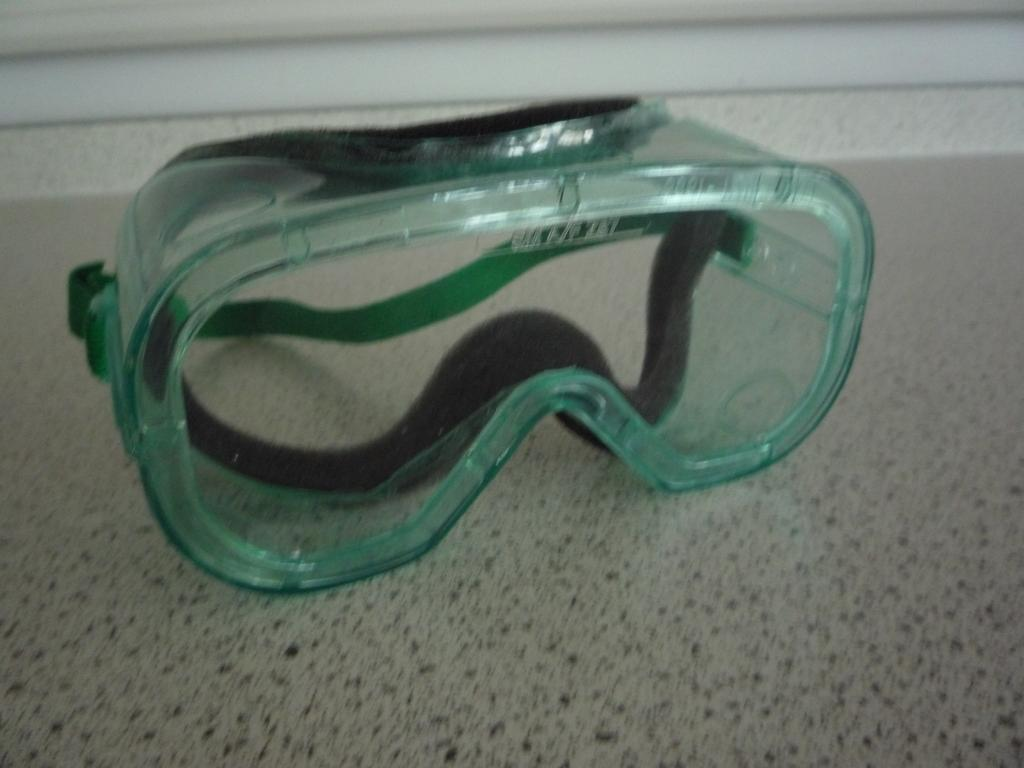What type of equipment is present in the image? There are swimming goggles in the image. Where are the swimming goggles located? The swimming goggles are kept on the floor. What is the swimming goggles' reaction to the fear of heights in the image? There is no fear of heights or any reaction to it in the image, as the image only features swimming goggles on the floor. 